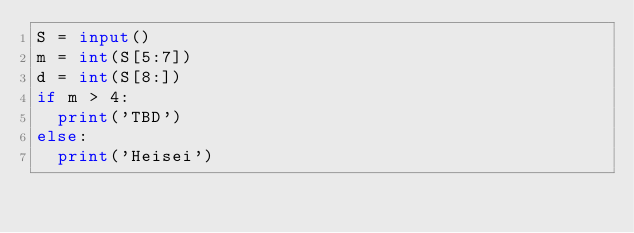Convert code to text. <code><loc_0><loc_0><loc_500><loc_500><_Python_>S = input()
m = int(S[5:7])
d = int(S[8:])
if m > 4:
  print('TBD')
else:
  print('Heisei')
</code> 